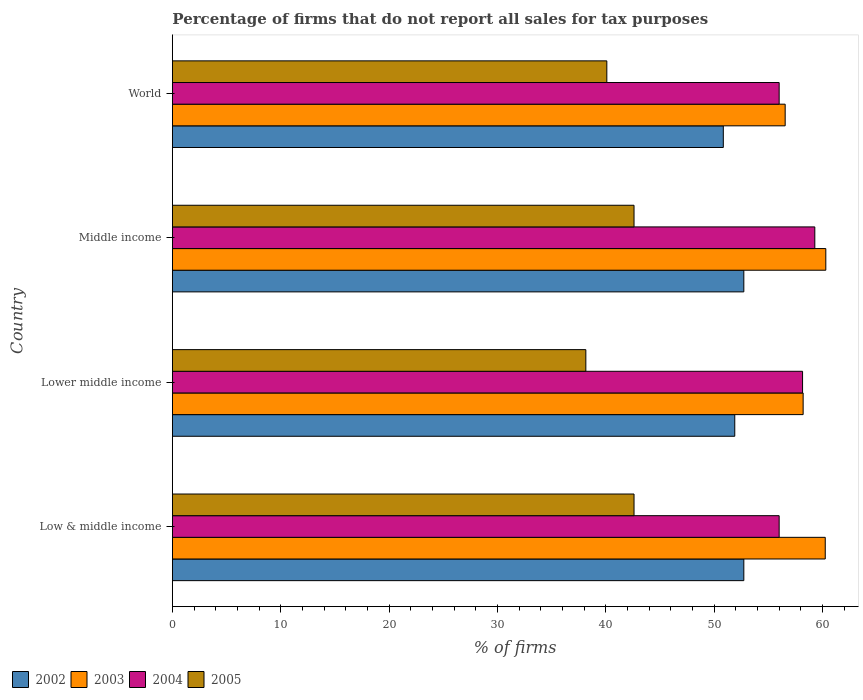How many different coloured bars are there?
Make the answer very short. 4. Are the number of bars per tick equal to the number of legend labels?
Ensure brevity in your answer.  Yes. Are the number of bars on each tick of the Y-axis equal?
Provide a short and direct response. Yes. How many bars are there on the 4th tick from the bottom?
Your answer should be compact. 4. What is the percentage of firms that do not report all sales for tax purposes in 2005 in Lower middle income?
Your response must be concise. 38.16. Across all countries, what is the maximum percentage of firms that do not report all sales for tax purposes in 2003?
Ensure brevity in your answer.  60.31. Across all countries, what is the minimum percentage of firms that do not report all sales for tax purposes in 2004?
Keep it short and to the point. 56.01. In which country was the percentage of firms that do not report all sales for tax purposes in 2003 maximum?
Offer a terse response. Middle income. What is the total percentage of firms that do not report all sales for tax purposes in 2002 in the graph?
Provide a short and direct response. 208.25. What is the difference between the percentage of firms that do not report all sales for tax purposes in 2004 in Middle income and that in World?
Your response must be concise. 3.29. What is the difference between the percentage of firms that do not report all sales for tax purposes in 2003 in Middle income and the percentage of firms that do not report all sales for tax purposes in 2004 in Low & middle income?
Offer a terse response. 4.31. What is the average percentage of firms that do not report all sales for tax purposes in 2003 per country?
Your response must be concise. 58.84. What is the difference between the percentage of firms that do not report all sales for tax purposes in 2005 and percentage of firms that do not report all sales for tax purposes in 2003 in World?
Keep it short and to the point. -16.46. What is the ratio of the percentage of firms that do not report all sales for tax purposes in 2002 in Middle income to that in World?
Offer a very short reply. 1.04. What is the difference between the highest and the second highest percentage of firms that do not report all sales for tax purposes in 2003?
Your response must be concise. 0.05. What is the difference between the highest and the lowest percentage of firms that do not report all sales for tax purposes in 2002?
Provide a succinct answer. 1.89. In how many countries, is the percentage of firms that do not report all sales for tax purposes in 2004 greater than the average percentage of firms that do not report all sales for tax purposes in 2004 taken over all countries?
Offer a very short reply. 2. Is it the case that in every country, the sum of the percentage of firms that do not report all sales for tax purposes in 2002 and percentage of firms that do not report all sales for tax purposes in 2004 is greater than the sum of percentage of firms that do not report all sales for tax purposes in 2005 and percentage of firms that do not report all sales for tax purposes in 2003?
Give a very brief answer. No. What does the 1st bar from the top in Lower middle income represents?
Ensure brevity in your answer.  2005. What does the 3rd bar from the bottom in Low & middle income represents?
Ensure brevity in your answer.  2004. Is it the case that in every country, the sum of the percentage of firms that do not report all sales for tax purposes in 2004 and percentage of firms that do not report all sales for tax purposes in 2003 is greater than the percentage of firms that do not report all sales for tax purposes in 2005?
Ensure brevity in your answer.  Yes. Are all the bars in the graph horizontal?
Give a very brief answer. Yes. How many countries are there in the graph?
Offer a terse response. 4. Are the values on the major ticks of X-axis written in scientific E-notation?
Offer a very short reply. No. Does the graph contain grids?
Make the answer very short. No. Where does the legend appear in the graph?
Keep it short and to the point. Bottom left. What is the title of the graph?
Offer a terse response. Percentage of firms that do not report all sales for tax purposes. Does "2013" appear as one of the legend labels in the graph?
Your answer should be very brief. No. What is the label or title of the X-axis?
Your answer should be compact. % of firms. What is the % of firms in 2002 in Low & middle income?
Provide a short and direct response. 52.75. What is the % of firms of 2003 in Low & middle income?
Offer a very short reply. 60.26. What is the % of firms in 2004 in Low & middle income?
Your response must be concise. 56.01. What is the % of firms in 2005 in Low & middle income?
Your answer should be very brief. 42.61. What is the % of firms of 2002 in Lower middle income?
Offer a terse response. 51.91. What is the % of firms in 2003 in Lower middle income?
Your answer should be compact. 58.22. What is the % of firms of 2004 in Lower middle income?
Provide a succinct answer. 58.16. What is the % of firms in 2005 in Lower middle income?
Offer a terse response. 38.16. What is the % of firms in 2002 in Middle income?
Keep it short and to the point. 52.75. What is the % of firms of 2003 in Middle income?
Ensure brevity in your answer.  60.31. What is the % of firms of 2004 in Middle income?
Provide a succinct answer. 59.3. What is the % of firms in 2005 in Middle income?
Offer a very short reply. 42.61. What is the % of firms in 2002 in World?
Offer a very short reply. 50.85. What is the % of firms in 2003 in World?
Make the answer very short. 56.56. What is the % of firms of 2004 in World?
Your response must be concise. 56.01. What is the % of firms of 2005 in World?
Your answer should be compact. 40.1. Across all countries, what is the maximum % of firms in 2002?
Offer a very short reply. 52.75. Across all countries, what is the maximum % of firms of 2003?
Offer a very short reply. 60.31. Across all countries, what is the maximum % of firms in 2004?
Offer a very short reply. 59.3. Across all countries, what is the maximum % of firms of 2005?
Offer a very short reply. 42.61. Across all countries, what is the minimum % of firms in 2002?
Ensure brevity in your answer.  50.85. Across all countries, what is the minimum % of firms in 2003?
Your answer should be compact. 56.56. Across all countries, what is the minimum % of firms of 2004?
Your response must be concise. 56.01. Across all countries, what is the minimum % of firms of 2005?
Ensure brevity in your answer.  38.16. What is the total % of firms of 2002 in the graph?
Your response must be concise. 208.25. What is the total % of firms of 2003 in the graph?
Provide a succinct answer. 235.35. What is the total % of firms of 2004 in the graph?
Your answer should be compact. 229.47. What is the total % of firms of 2005 in the graph?
Your response must be concise. 163.48. What is the difference between the % of firms of 2002 in Low & middle income and that in Lower middle income?
Provide a short and direct response. 0.84. What is the difference between the % of firms in 2003 in Low & middle income and that in Lower middle income?
Provide a succinct answer. 2.04. What is the difference between the % of firms in 2004 in Low & middle income and that in Lower middle income?
Offer a terse response. -2.16. What is the difference between the % of firms in 2005 in Low & middle income and that in Lower middle income?
Offer a very short reply. 4.45. What is the difference between the % of firms of 2002 in Low & middle income and that in Middle income?
Keep it short and to the point. 0. What is the difference between the % of firms in 2003 in Low & middle income and that in Middle income?
Give a very brief answer. -0.05. What is the difference between the % of firms of 2004 in Low & middle income and that in Middle income?
Provide a succinct answer. -3.29. What is the difference between the % of firms in 2005 in Low & middle income and that in Middle income?
Give a very brief answer. 0. What is the difference between the % of firms in 2002 in Low & middle income and that in World?
Your response must be concise. 1.89. What is the difference between the % of firms of 2005 in Low & middle income and that in World?
Your answer should be very brief. 2.51. What is the difference between the % of firms in 2002 in Lower middle income and that in Middle income?
Ensure brevity in your answer.  -0.84. What is the difference between the % of firms in 2003 in Lower middle income and that in Middle income?
Ensure brevity in your answer.  -2.09. What is the difference between the % of firms in 2004 in Lower middle income and that in Middle income?
Provide a succinct answer. -1.13. What is the difference between the % of firms in 2005 in Lower middle income and that in Middle income?
Give a very brief answer. -4.45. What is the difference between the % of firms in 2002 in Lower middle income and that in World?
Your answer should be very brief. 1.06. What is the difference between the % of firms in 2003 in Lower middle income and that in World?
Provide a short and direct response. 1.66. What is the difference between the % of firms of 2004 in Lower middle income and that in World?
Provide a short and direct response. 2.16. What is the difference between the % of firms in 2005 in Lower middle income and that in World?
Your answer should be very brief. -1.94. What is the difference between the % of firms of 2002 in Middle income and that in World?
Your response must be concise. 1.89. What is the difference between the % of firms of 2003 in Middle income and that in World?
Make the answer very short. 3.75. What is the difference between the % of firms in 2004 in Middle income and that in World?
Make the answer very short. 3.29. What is the difference between the % of firms in 2005 in Middle income and that in World?
Your response must be concise. 2.51. What is the difference between the % of firms in 2002 in Low & middle income and the % of firms in 2003 in Lower middle income?
Make the answer very short. -5.47. What is the difference between the % of firms of 2002 in Low & middle income and the % of firms of 2004 in Lower middle income?
Offer a very short reply. -5.42. What is the difference between the % of firms of 2002 in Low & middle income and the % of firms of 2005 in Lower middle income?
Your response must be concise. 14.58. What is the difference between the % of firms in 2003 in Low & middle income and the % of firms in 2004 in Lower middle income?
Give a very brief answer. 2.1. What is the difference between the % of firms of 2003 in Low & middle income and the % of firms of 2005 in Lower middle income?
Give a very brief answer. 22.1. What is the difference between the % of firms of 2004 in Low & middle income and the % of firms of 2005 in Lower middle income?
Offer a very short reply. 17.84. What is the difference between the % of firms in 2002 in Low & middle income and the % of firms in 2003 in Middle income?
Make the answer very short. -7.57. What is the difference between the % of firms in 2002 in Low & middle income and the % of firms in 2004 in Middle income?
Offer a terse response. -6.55. What is the difference between the % of firms of 2002 in Low & middle income and the % of firms of 2005 in Middle income?
Offer a very short reply. 10.13. What is the difference between the % of firms of 2003 in Low & middle income and the % of firms of 2004 in Middle income?
Your answer should be compact. 0.96. What is the difference between the % of firms in 2003 in Low & middle income and the % of firms in 2005 in Middle income?
Offer a very short reply. 17.65. What is the difference between the % of firms in 2004 in Low & middle income and the % of firms in 2005 in Middle income?
Your answer should be very brief. 13.39. What is the difference between the % of firms of 2002 in Low & middle income and the % of firms of 2003 in World?
Give a very brief answer. -3.81. What is the difference between the % of firms in 2002 in Low & middle income and the % of firms in 2004 in World?
Ensure brevity in your answer.  -3.26. What is the difference between the % of firms of 2002 in Low & middle income and the % of firms of 2005 in World?
Your response must be concise. 12.65. What is the difference between the % of firms of 2003 in Low & middle income and the % of firms of 2004 in World?
Your answer should be compact. 4.25. What is the difference between the % of firms in 2003 in Low & middle income and the % of firms in 2005 in World?
Provide a succinct answer. 20.16. What is the difference between the % of firms of 2004 in Low & middle income and the % of firms of 2005 in World?
Keep it short and to the point. 15.91. What is the difference between the % of firms in 2002 in Lower middle income and the % of firms in 2003 in Middle income?
Your response must be concise. -8.4. What is the difference between the % of firms of 2002 in Lower middle income and the % of firms of 2004 in Middle income?
Keep it short and to the point. -7.39. What is the difference between the % of firms of 2002 in Lower middle income and the % of firms of 2005 in Middle income?
Make the answer very short. 9.3. What is the difference between the % of firms in 2003 in Lower middle income and the % of firms in 2004 in Middle income?
Provide a short and direct response. -1.08. What is the difference between the % of firms of 2003 in Lower middle income and the % of firms of 2005 in Middle income?
Keep it short and to the point. 15.61. What is the difference between the % of firms of 2004 in Lower middle income and the % of firms of 2005 in Middle income?
Keep it short and to the point. 15.55. What is the difference between the % of firms of 2002 in Lower middle income and the % of firms of 2003 in World?
Make the answer very short. -4.65. What is the difference between the % of firms in 2002 in Lower middle income and the % of firms in 2004 in World?
Keep it short and to the point. -4.1. What is the difference between the % of firms in 2002 in Lower middle income and the % of firms in 2005 in World?
Your answer should be compact. 11.81. What is the difference between the % of firms in 2003 in Lower middle income and the % of firms in 2004 in World?
Keep it short and to the point. 2.21. What is the difference between the % of firms of 2003 in Lower middle income and the % of firms of 2005 in World?
Provide a short and direct response. 18.12. What is the difference between the % of firms of 2004 in Lower middle income and the % of firms of 2005 in World?
Your answer should be compact. 18.07. What is the difference between the % of firms of 2002 in Middle income and the % of firms of 2003 in World?
Your answer should be compact. -3.81. What is the difference between the % of firms in 2002 in Middle income and the % of firms in 2004 in World?
Your answer should be compact. -3.26. What is the difference between the % of firms of 2002 in Middle income and the % of firms of 2005 in World?
Ensure brevity in your answer.  12.65. What is the difference between the % of firms of 2003 in Middle income and the % of firms of 2004 in World?
Your answer should be very brief. 4.31. What is the difference between the % of firms in 2003 in Middle income and the % of firms in 2005 in World?
Provide a succinct answer. 20.21. What is the difference between the % of firms of 2004 in Middle income and the % of firms of 2005 in World?
Keep it short and to the point. 19.2. What is the average % of firms of 2002 per country?
Provide a short and direct response. 52.06. What is the average % of firms of 2003 per country?
Ensure brevity in your answer.  58.84. What is the average % of firms of 2004 per country?
Make the answer very short. 57.37. What is the average % of firms in 2005 per country?
Make the answer very short. 40.87. What is the difference between the % of firms of 2002 and % of firms of 2003 in Low & middle income?
Make the answer very short. -7.51. What is the difference between the % of firms of 2002 and % of firms of 2004 in Low & middle income?
Keep it short and to the point. -3.26. What is the difference between the % of firms in 2002 and % of firms in 2005 in Low & middle income?
Ensure brevity in your answer.  10.13. What is the difference between the % of firms of 2003 and % of firms of 2004 in Low & middle income?
Your answer should be compact. 4.25. What is the difference between the % of firms in 2003 and % of firms in 2005 in Low & middle income?
Give a very brief answer. 17.65. What is the difference between the % of firms in 2004 and % of firms in 2005 in Low & middle income?
Provide a short and direct response. 13.39. What is the difference between the % of firms of 2002 and % of firms of 2003 in Lower middle income?
Offer a terse response. -6.31. What is the difference between the % of firms of 2002 and % of firms of 2004 in Lower middle income?
Keep it short and to the point. -6.26. What is the difference between the % of firms in 2002 and % of firms in 2005 in Lower middle income?
Keep it short and to the point. 13.75. What is the difference between the % of firms of 2003 and % of firms of 2004 in Lower middle income?
Keep it short and to the point. 0.05. What is the difference between the % of firms in 2003 and % of firms in 2005 in Lower middle income?
Make the answer very short. 20.06. What is the difference between the % of firms in 2004 and % of firms in 2005 in Lower middle income?
Provide a short and direct response. 20. What is the difference between the % of firms of 2002 and % of firms of 2003 in Middle income?
Your response must be concise. -7.57. What is the difference between the % of firms in 2002 and % of firms in 2004 in Middle income?
Provide a short and direct response. -6.55. What is the difference between the % of firms in 2002 and % of firms in 2005 in Middle income?
Offer a terse response. 10.13. What is the difference between the % of firms of 2003 and % of firms of 2004 in Middle income?
Your response must be concise. 1.02. What is the difference between the % of firms in 2003 and % of firms in 2005 in Middle income?
Ensure brevity in your answer.  17.7. What is the difference between the % of firms in 2004 and % of firms in 2005 in Middle income?
Provide a short and direct response. 16.69. What is the difference between the % of firms in 2002 and % of firms in 2003 in World?
Provide a short and direct response. -5.71. What is the difference between the % of firms of 2002 and % of firms of 2004 in World?
Ensure brevity in your answer.  -5.15. What is the difference between the % of firms of 2002 and % of firms of 2005 in World?
Your answer should be very brief. 10.75. What is the difference between the % of firms in 2003 and % of firms in 2004 in World?
Keep it short and to the point. 0.56. What is the difference between the % of firms of 2003 and % of firms of 2005 in World?
Keep it short and to the point. 16.46. What is the difference between the % of firms of 2004 and % of firms of 2005 in World?
Your response must be concise. 15.91. What is the ratio of the % of firms of 2002 in Low & middle income to that in Lower middle income?
Offer a terse response. 1.02. What is the ratio of the % of firms of 2003 in Low & middle income to that in Lower middle income?
Keep it short and to the point. 1.04. What is the ratio of the % of firms of 2004 in Low & middle income to that in Lower middle income?
Provide a short and direct response. 0.96. What is the ratio of the % of firms in 2005 in Low & middle income to that in Lower middle income?
Your answer should be very brief. 1.12. What is the ratio of the % of firms of 2004 in Low & middle income to that in Middle income?
Provide a succinct answer. 0.94. What is the ratio of the % of firms of 2002 in Low & middle income to that in World?
Your answer should be very brief. 1.04. What is the ratio of the % of firms of 2003 in Low & middle income to that in World?
Make the answer very short. 1.07. What is the ratio of the % of firms in 2005 in Low & middle income to that in World?
Ensure brevity in your answer.  1.06. What is the ratio of the % of firms of 2002 in Lower middle income to that in Middle income?
Offer a very short reply. 0.98. What is the ratio of the % of firms in 2003 in Lower middle income to that in Middle income?
Keep it short and to the point. 0.97. What is the ratio of the % of firms of 2004 in Lower middle income to that in Middle income?
Offer a terse response. 0.98. What is the ratio of the % of firms in 2005 in Lower middle income to that in Middle income?
Ensure brevity in your answer.  0.9. What is the ratio of the % of firms in 2002 in Lower middle income to that in World?
Ensure brevity in your answer.  1.02. What is the ratio of the % of firms in 2003 in Lower middle income to that in World?
Offer a terse response. 1.03. What is the ratio of the % of firms in 2004 in Lower middle income to that in World?
Give a very brief answer. 1.04. What is the ratio of the % of firms of 2005 in Lower middle income to that in World?
Your response must be concise. 0.95. What is the ratio of the % of firms in 2002 in Middle income to that in World?
Your response must be concise. 1.04. What is the ratio of the % of firms of 2003 in Middle income to that in World?
Your response must be concise. 1.07. What is the ratio of the % of firms in 2004 in Middle income to that in World?
Keep it short and to the point. 1.06. What is the ratio of the % of firms in 2005 in Middle income to that in World?
Your answer should be very brief. 1.06. What is the difference between the highest and the second highest % of firms of 2002?
Your answer should be very brief. 0. What is the difference between the highest and the second highest % of firms in 2003?
Your response must be concise. 0.05. What is the difference between the highest and the second highest % of firms of 2004?
Give a very brief answer. 1.13. What is the difference between the highest and the lowest % of firms in 2002?
Provide a short and direct response. 1.89. What is the difference between the highest and the lowest % of firms of 2003?
Provide a succinct answer. 3.75. What is the difference between the highest and the lowest % of firms in 2004?
Offer a terse response. 3.29. What is the difference between the highest and the lowest % of firms of 2005?
Offer a very short reply. 4.45. 